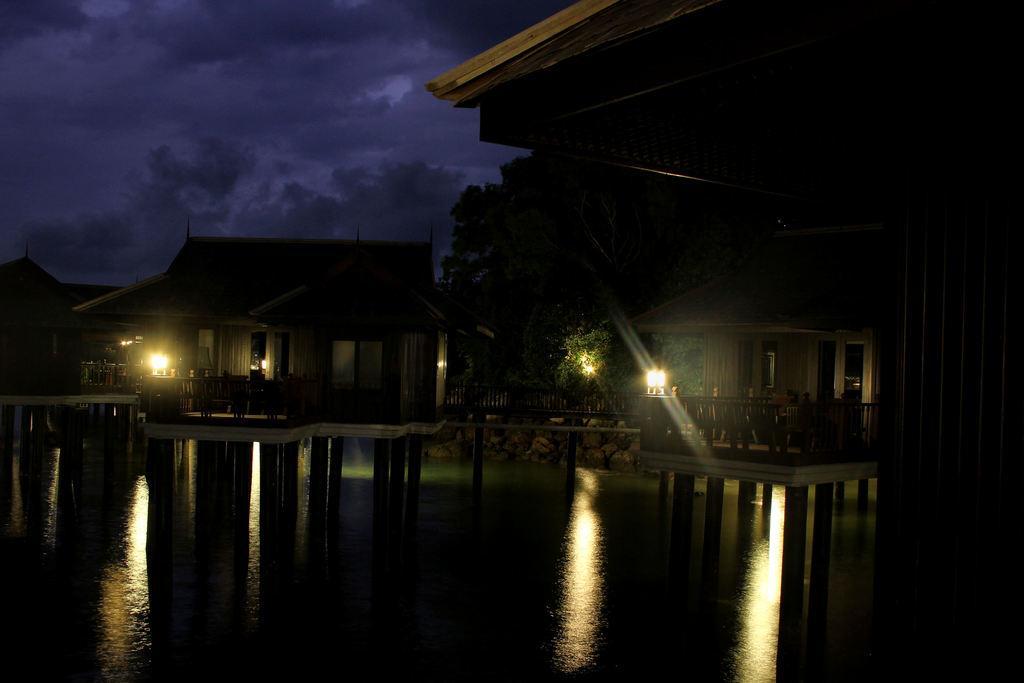How would you summarize this image in a sentence or two? In front of the image there is water. There are wooden houses, poles, trees, lamps and railings. At the top of the image there are clouds in the sky. 